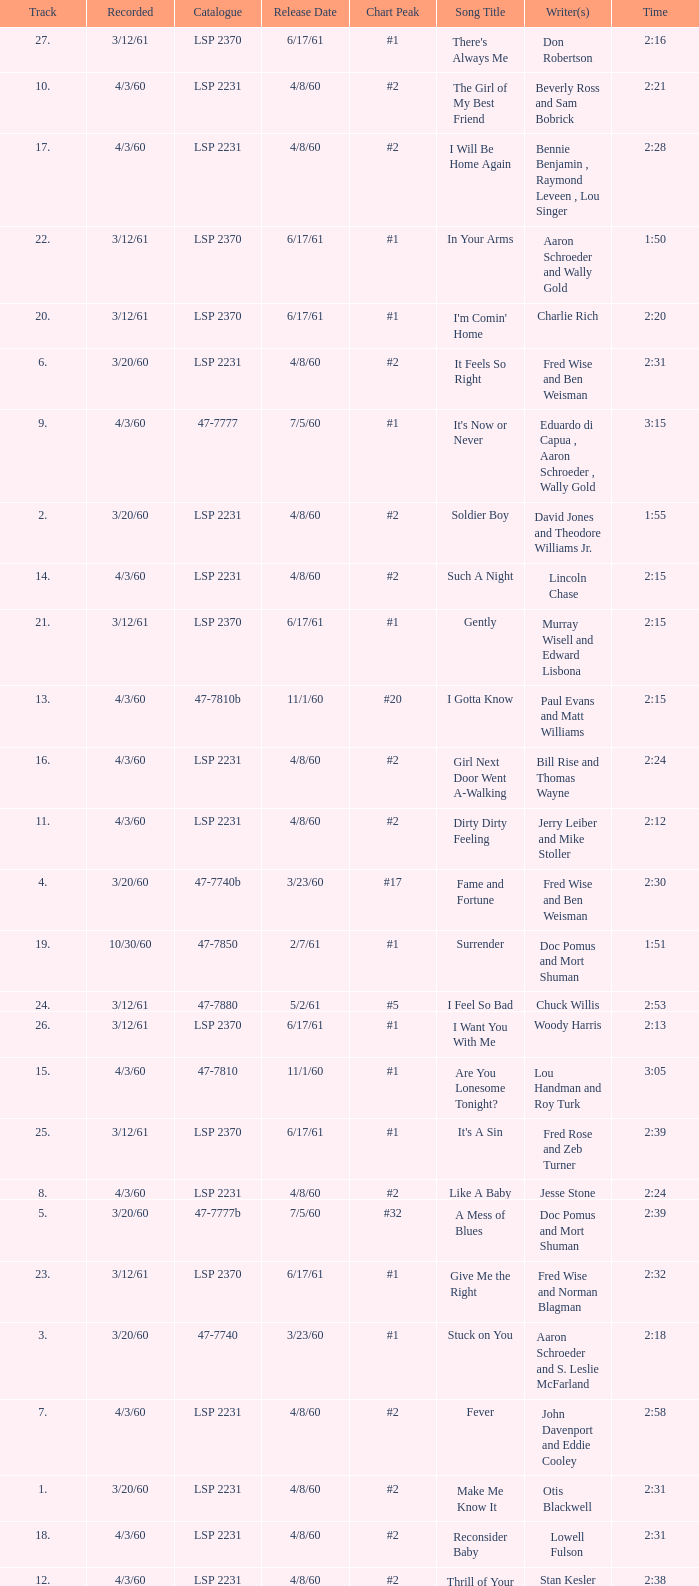What catalogue is the song It's Now or Never? 47-7777. 